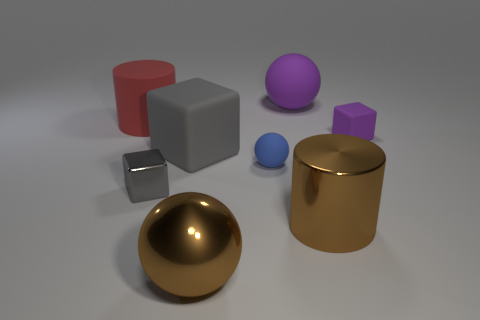Add 1 brown rubber blocks. How many objects exist? 9 Subtract all cylinders. How many objects are left? 6 Add 3 blue matte balls. How many blue matte balls exist? 4 Subtract 1 brown cylinders. How many objects are left? 7 Subtract all tiny blue balls. Subtract all brown cylinders. How many objects are left? 6 Add 2 blue balls. How many blue balls are left? 3 